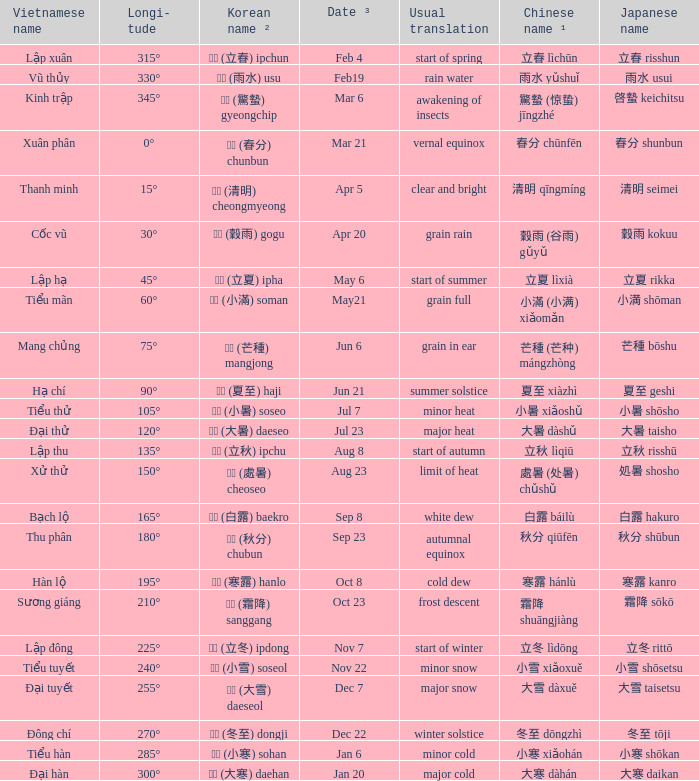Which Longi- tude is on jun 6? 75°. 